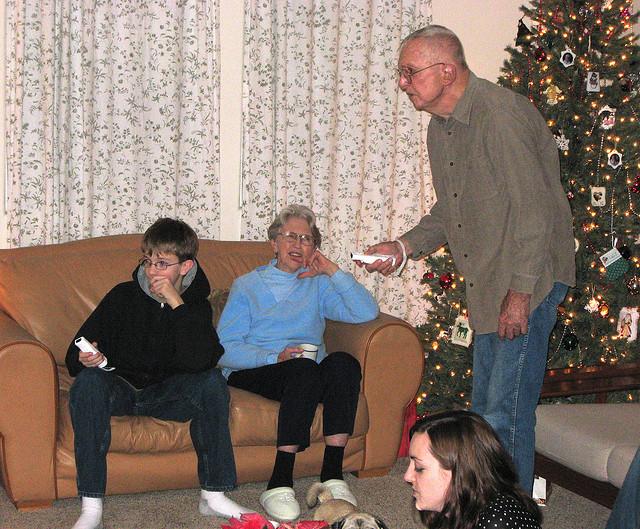What does the man have in his hand?
Answer briefly. Wii remote. What holiday is represented by this picture?
Be succinct. Christmas. Are they playing inside?
Concise answer only. Yes. 